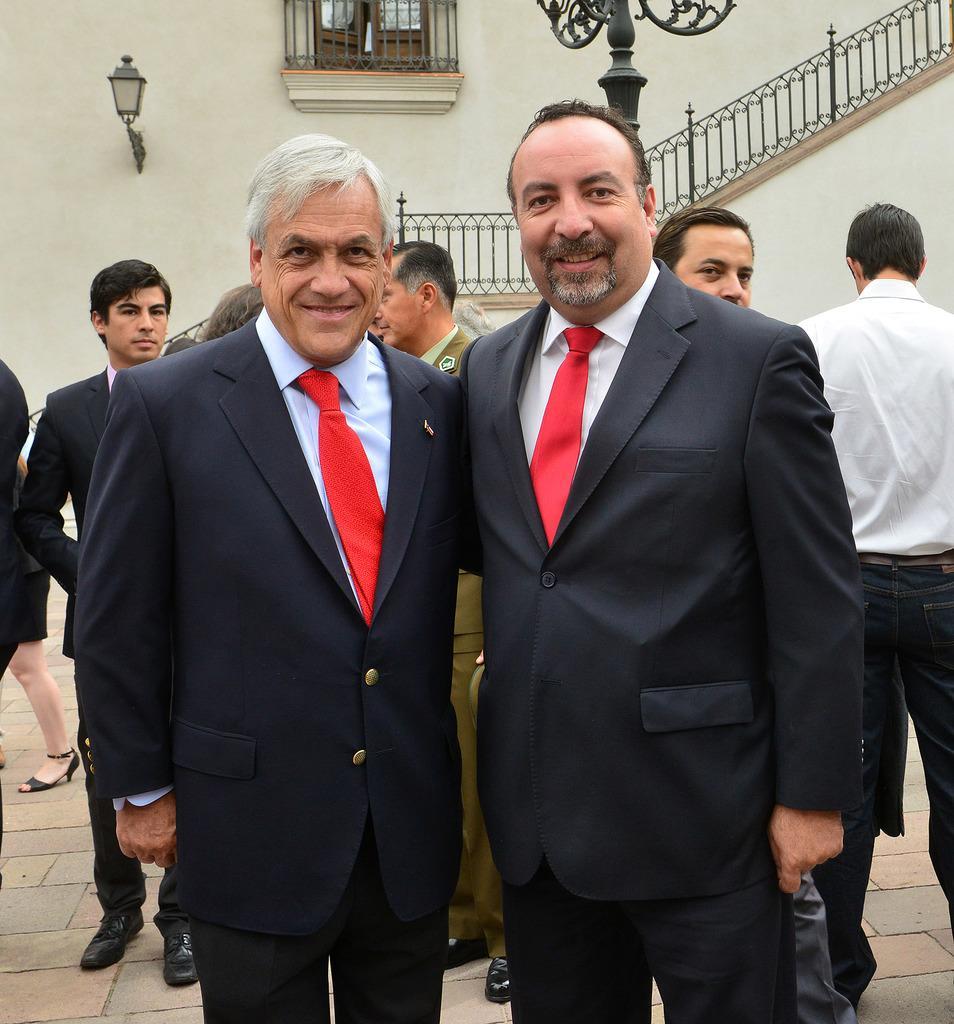Please provide a concise description of this image. In this image there are two persons standing and smiling, and in the background there are group of people standing, window, light and staircase of a building. 